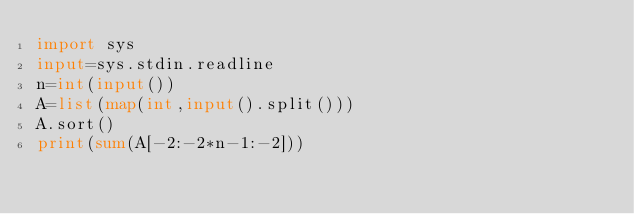<code> <loc_0><loc_0><loc_500><loc_500><_Python_>import sys
input=sys.stdin.readline
n=int(input())
A=list(map(int,input().split()))
A.sort()
print(sum(A[-2:-2*n-1:-2]))</code> 